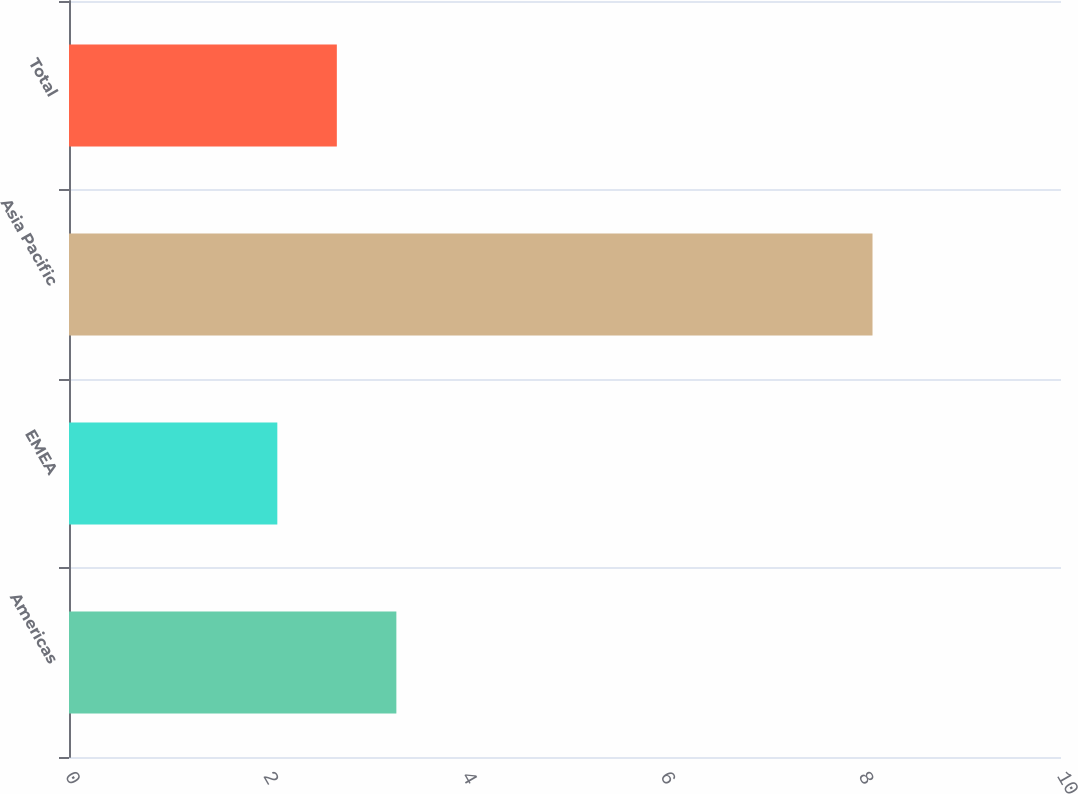Convert chart. <chart><loc_0><loc_0><loc_500><loc_500><bar_chart><fcel>Americas<fcel>EMEA<fcel>Asia Pacific<fcel>Total<nl><fcel>3.3<fcel>2.1<fcel>8.1<fcel>2.7<nl></chart> 